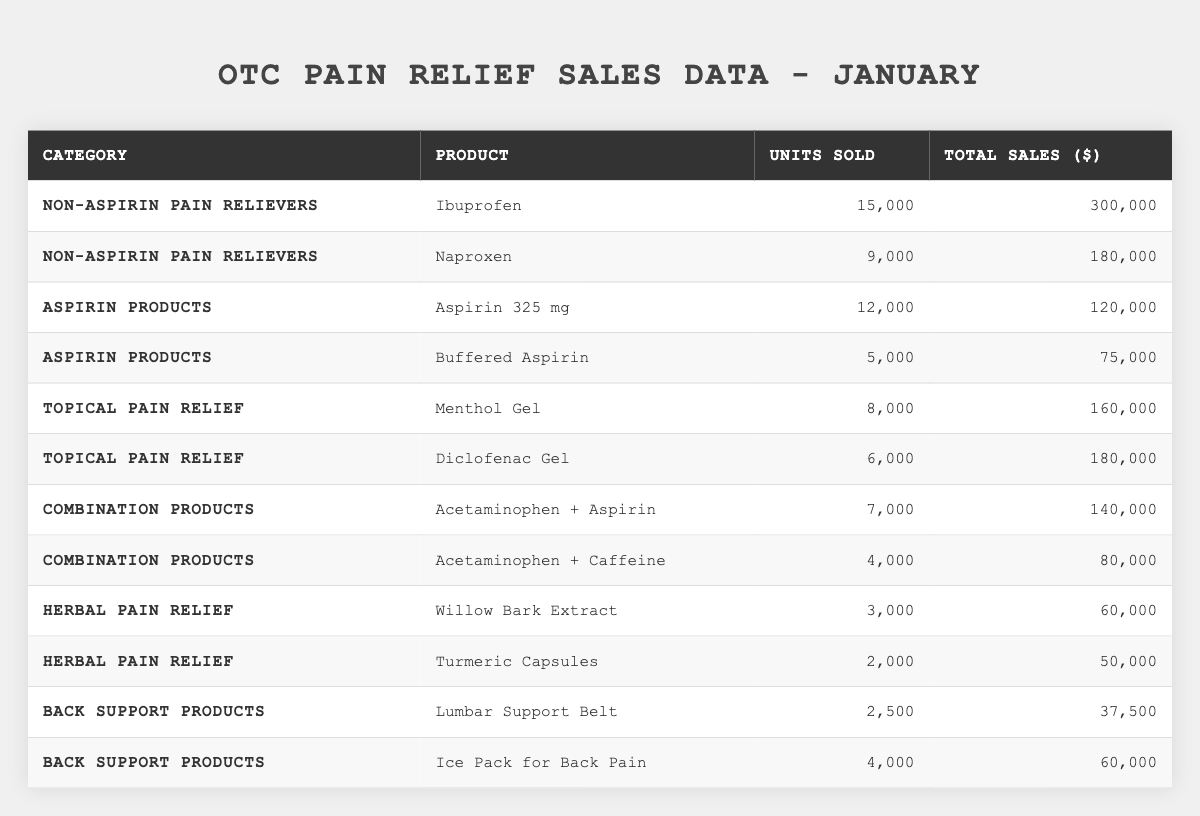What is the highest-selling product in the Non-aspirin Pain Relievers category? The products in the Non-aspirin Pain Relievers category are Ibuprofen with 15,000 units sold and Naproxen with 9,000 units sold. Since Ibuprofen has more units sold, it is the highest-selling product.
Answer: Ibuprofen How many units of Aspirin 325 mg were sold? The table directly lists the units sold for Aspirin 325 mg as 12,000.
Answer: 12,000 What are the total sales for Back Support Products combined? The total sales for Back Support Products are calculated by adding the total sales of Lumbar Support Belt ($37,500) and Ice Pack for Back Pain ($60,000): 37,500 + 60,000 = 97,500.
Answer: 97,500 Is the total sales for Topical Pain Relief greater than that of Combination Products? The total sales for Topical Pain Relief is 160,000 (Menthol Gel) + 180,000 (Diclofenac Gel) = 340,000. For Combination Products, it is 140,000 (Acetaminophen + Aspirin) + 80,000 (Acetaminophen + Caffeine) = 220,000. Since 340,000 > 220,000, the statement is true.
Answer: Yes What percentage of total sales does Ibuprofen account for in the Non-aspirin Pain Relievers category? The total sales for Non-aspirin Pain Relievers is 300,000 (Ibuprofen) + 180,000 (Naproxen) = 480,000. The percentage for Ibuprofen is (300,000 / 480,000) * 100 = 62.5%.
Answer: 62.5% Which product in the Combination Products category had the lowest total sales, and what was that amount? In the Combination Products category, Acetaminophen + Aspirin had total sales of 140,000, and Acetaminophen + Caffeine had total sales of 80,000. Since 80,000 is lower, Acetaminophen + Caffeine is the product with the lowest sales.
Answer: Acetaminophen + Caffeine, 80,000 What is the average number of units sold for all Herbal Pain Relief products? The total units sold for Herbal Pain Relief products are 3,000 (Willow Bark Extract) + 2,000 (Turmeric Capsules) = 5,000. There are 2 products, so the average is 5,000 / 2 = 2,500.
Answer: 2,500 Which category had the highest total sales, and what was the total amount? By summing the total sales for each category: Non-aspirin Pain Relievers = 480,000, Aspirin Products = 195,000, Topical Pain Relief = 340,000, Combination Products = 220,000, Herbal Pain Relief = 110,000, and Back Support Products = 97,500. The highest total sales category is Non-aspirin Pain Relievers with 480,000.
Answer: Non-aspirin Pain Relievers, 480,000 How many more units were sold for Ice Pack for Back Pain compared to Lumbar Support Belt? Ice Pack for Back Pain sold 4,000 units, while Lumbar Support Belt sold 2,500. The difference is 4,000 - 2,500 = 1,500 units.
Answer: 1,500 Is the total number of units sold for Topical Pain Relief greater than that for Herbal Pain Relief? The total units sold for Topical Pain Relief is 8,000 (Menthol Gel) + 6,000 (Diclofenac Gel) = 14,000. The total for Herbal Pain Relief is 3,000 (Willow Bark Extract) + 2,000 (Turmeric Capsules) = 5,000. Since 14,000 is greater than 5,000, the statement is true.
Answer: Yes 